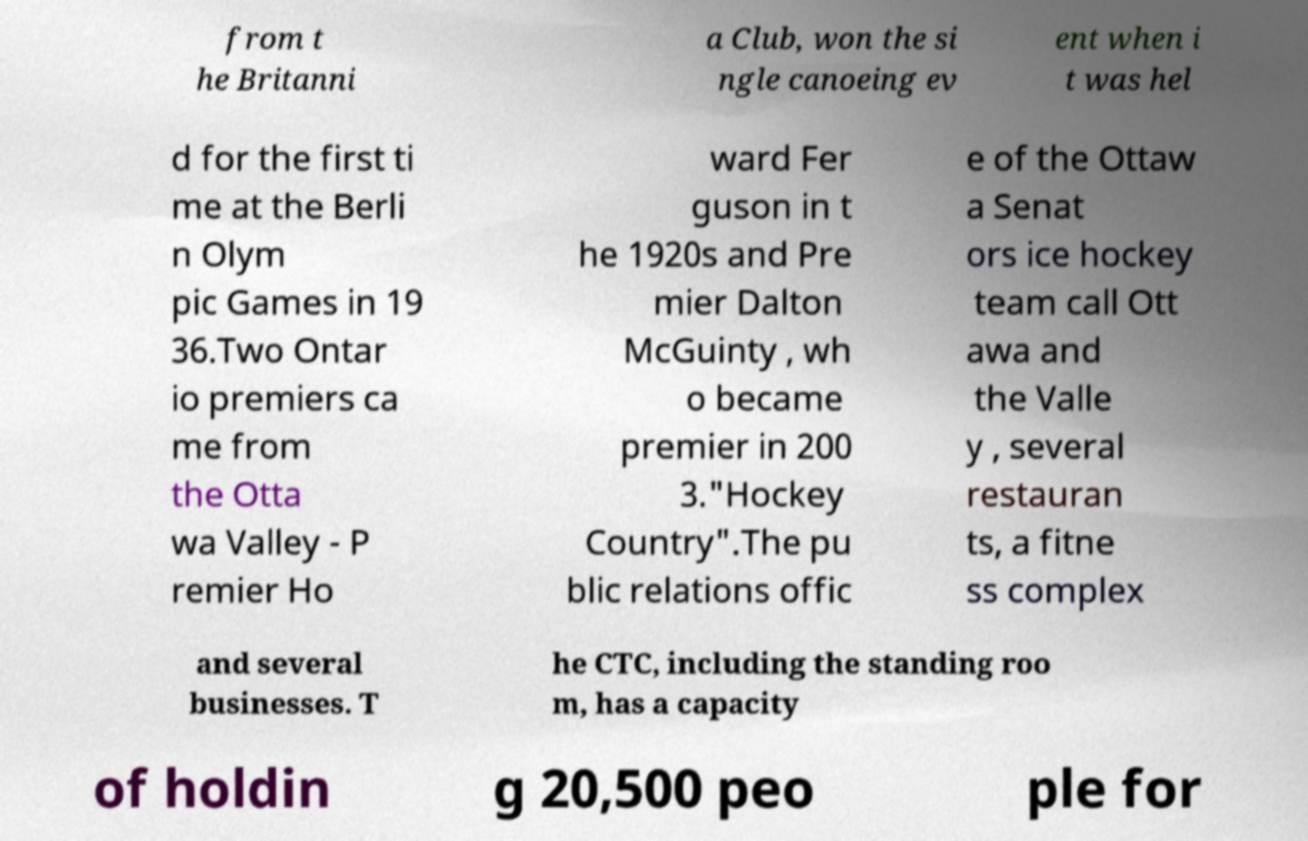For documentation purposes, I need the text within this image transcribed. Could you provide that? from t he Britanni a Club, won the si ngle canoeing ev ent when i t was hel d for the first ti me at the Berli n Olym pic Games in 19 36.Two Ontar io premiers ca me from the Otta wa Valley - P remier Ho ward Fer guson in t he 1920s and Pre mier Dalton McGuinty , wh o became premier in 200 3."Hockey Country".The pu blic relations offic e of the Ottaw a Senat ors ice hockey team call Ott awa and the Valle y , several restauran ts, a fitne ss complex and several businesses. T he CTC, including the standing roo m, has a capacity of holdin g 20,500 peo ple for 